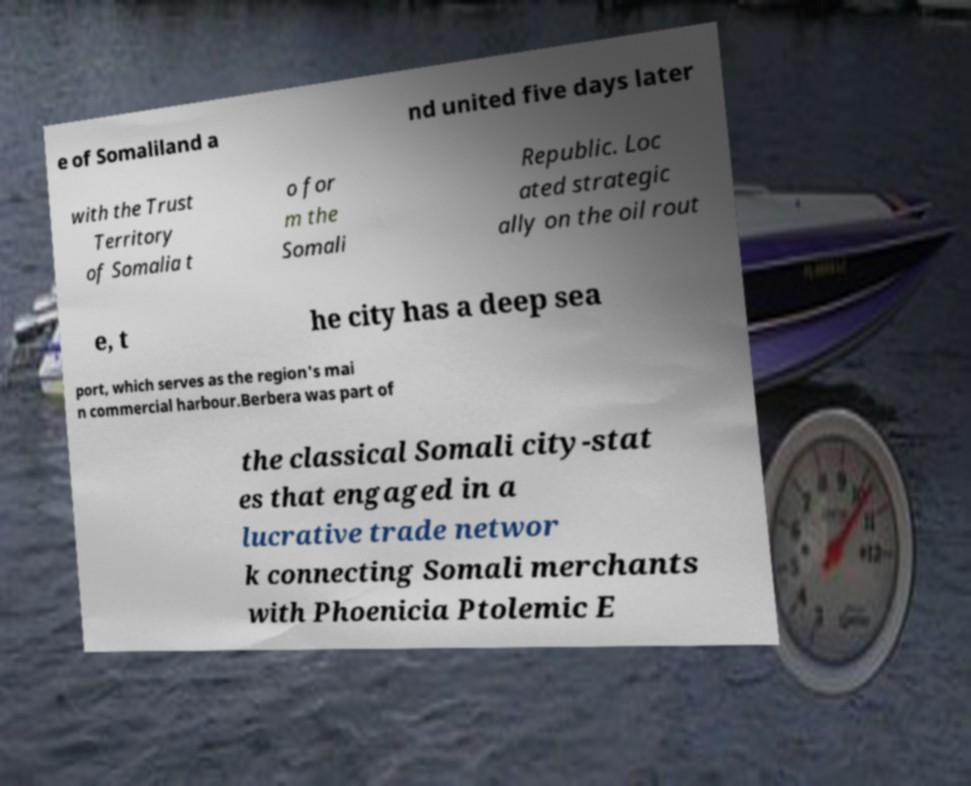I need the written content from this picture converted into text. Can you do that? e of Somaliland a nd united five days later with the Trust Territory of Somalia t o for m the Somali Republic. Loc ated strategic ally on the oil rout e, t he city has a deep sea port, which serves as the region's mai n commercial harbour.Berbera was part of the classical Somali city-stat es that engaged in a lucrative trade networ k connecting Somali merchants with Phoenicia Ptolemic E 